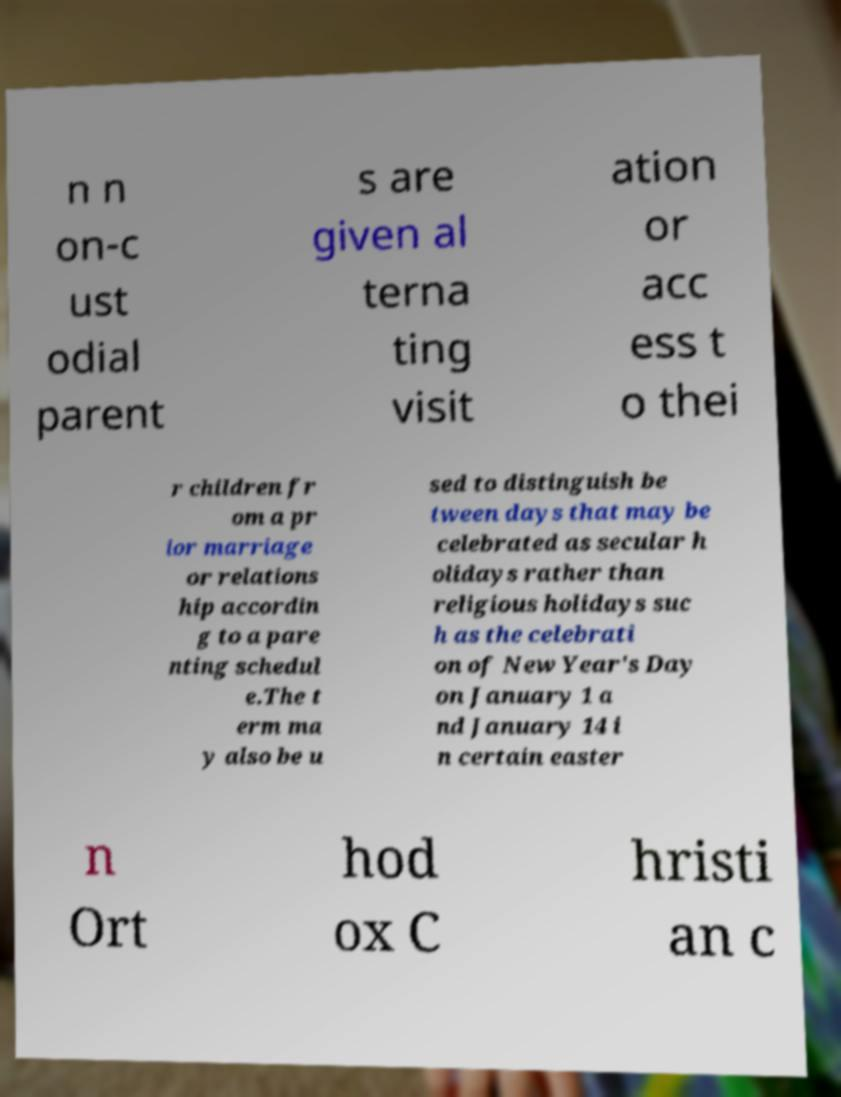Can you accurately transcribe the text from the provided image for me? n n on-c ust odial parent s are given al terna ting visit ation or acc ess t o thei r children fr om a pr ior marriage or relations hip accordin g to a pare nting schedul e.The t erm ma y also be u sed to distinguish be tween days that may be celebrated as secular h olidays rather than religious holidays suc h as the celebrati on of New Year's Day on January 1 a nd January 14 i n certain easter n Ort hod ox C hristi an c 